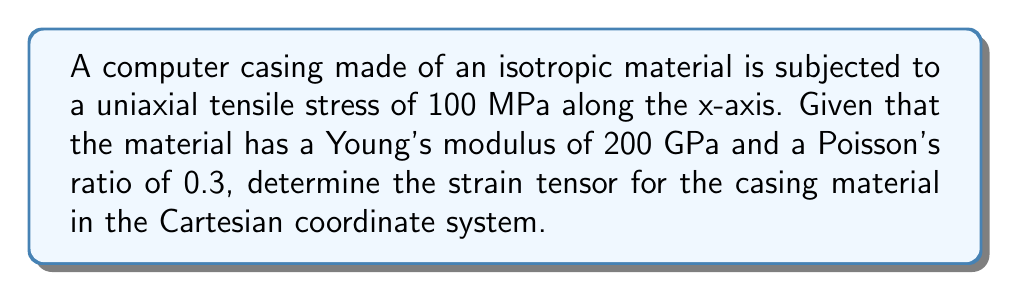Help me with this question. To determine the strain tensor, we'll follow these steps:

1) For a uniaxial stress state, the stress tensor is:

   $$\sigma_{ij} = \begin{bmatrix}
   100 & 0 & 0 \\
   0 & 0 & 0 \\
   0 & 0 & 0
   \end{bmatrix} \text{ MPa}$$

2) For an isotropic material under uniaxial stress, we can use Hooke's law:

   $$\varepsilon_{xx} = \frac{\sigma_{xx}}{E} = \frac{100}{200000} = 0.0005$$

3) The lateral strains can be calculated using Poisson's ratio:

   $$\varepsilon_{yy} = \varepsilon_{zz} = -\nu \varepsilon_{xx} = -0.3 \times 0.0005 = -0.00015$$

4) For this simple loading case, shear strains are zero:

   $$\varepsilon_{xy} = \varepsilon_{yz} = \varepsilon_{xz} = 0$$

5) Now we can construct the strain tensor:

   $$\varepsilon_{ij} = \begin{bmatrix}
   \varepsilon_{xx} & \varepsilon_{xy} & \varepsilon_{xz} \\
   \varepsilon_{yx} & \varepsilon_{yy} & \varepsilon_{yz} \\
   \varepsilon_{zx} & \varepsilon_{zy} & \varepsilon_{zz}
   \end{bmatrix} = \begin{bmatrix}
   0.0005 & 0 & 0 \\
   0 & -0.00015 & 0 \\
   0 & 0 & -0.00015
   \end{bmatrix}$$

This strain tensor fully describes the deformation of the computer casing material under the given load.
Answer: $$\varepsilon_{ij} = \begin{bmatrix}
0.0005 & 0 & 0 \\
0 & -0.00015 & 0 \\
0 & 0 & -0.00015
\end{bmatrix}$$ 